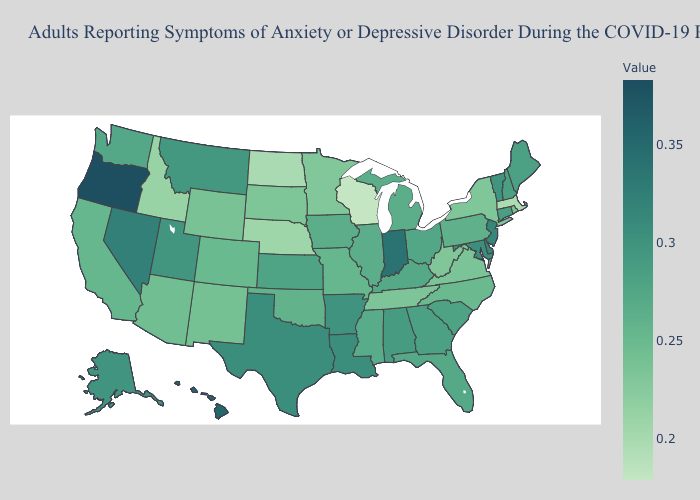Which states have the lowest value in the West?
Keep it brief. Idaho. Does Massachusetts have the lowest value in the Northeast?
Answer briefly. Yes. Does Delaware have the highest value in the South?
Short answer required. Yes. Among the states that border Connecticut , does Massachusetts have the lowest value?
Quick response, please. Yes. Among the states that border Vermont , does New Hampshire have the highest value?
Quick response, please. Yes. Does Oregon have the highest value in the West?
Concise answer only. Yes. 